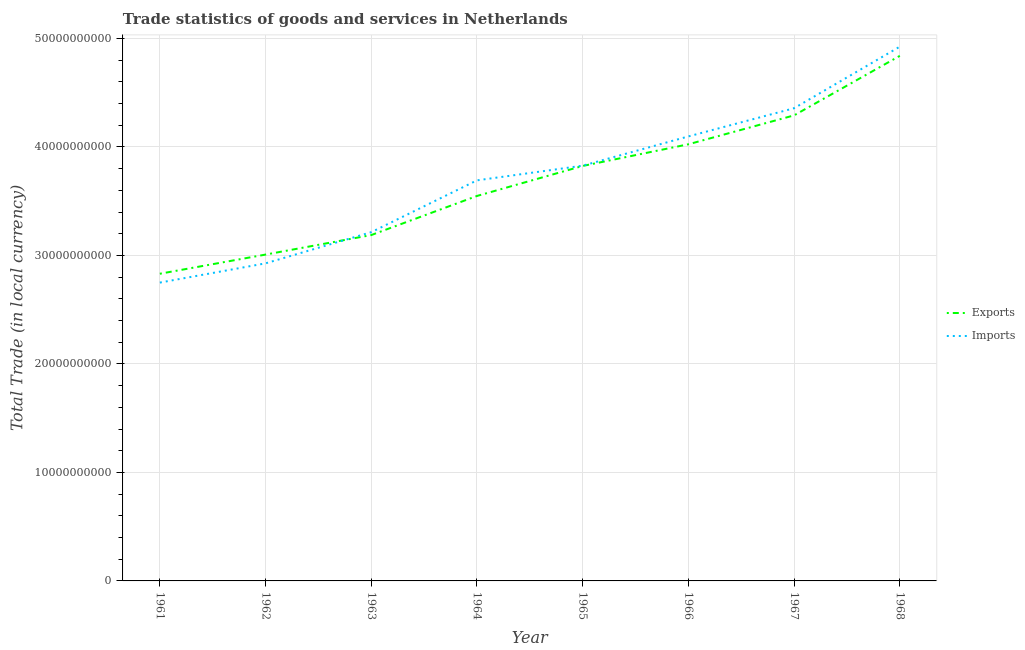Is the number of lines equal to the number of legend labels?
Give a very brief answer. Yes. What is the export of goods and services in 1962?
Make the answer very short. 3.01e+1. Across all years, what is the maximum export of goods and services?
Provide a short and direct response. 4.84e+1. Across all years, what is the minimum imports of goods and services?
Your response must be concise. 2.75e+1. In which year was the export of goods and services maximum?
Your response must be concise. 1968. What is the total export of goods and services in the graph?
Offer a terse response. 2.96e+11. What is the difference between the export of goods and services in 1962 and that in 1963?
Your response must be concise. -1.80e+09. What is the difference between the export of goods and services in 1964 and the imports of goods and services in 1965?
Provide a succinct answer. -2.79e+09. What is the average export of goods and services per year?
Provide a succinct answer. 3.69e+1. In the year 1963, what is the difference between the imports of goods and services and export of goods and services?
Provide a succinct answer. 2.67e+08. In how many years, is the export of goods and services greater than 46000000000 LCU?
Provide a short and direct response. 1. What is the ratio of the imports of goods and services in 1962 to that in 1964?
Provide a succinct answer. 0.79. Is the imports of goods and services in 1967 less than that in 1968?
Give a very brief answer. Yes. Is the difference between the export of goods and services in 1961 and 1966 greater than the difference between the imports of goods and services in 1961 and 1966?
Your answer should be very brief. Yes. What is the difference between the highest and the second highest imports of goods and services?
Your response must be concise. 5.67e+09. What is the difference between the highest and the lowest imports of goods and services?
Your response must be concise. 2.17e+1. Does the imports of goods and services monotonically increase over the years?
Give a very brief answer. Yes. How many years are there in the graph?
Make the answer very short. 8. What is the difference between two consecutive major ticks on the Y-axis?
Keep it short and to the point. 1.00e+1. Are the values on the major ticks of Y-axis written in scientific E-notation?
Your response must be concise. No. Does the graph contain any zero values?
Provide a short and direct response. No. Does the graph contain grids?
Your answer should be very brief. Yes. Where does the legend appear in the graph?
Keep it short and to the point. Center right. What is the title of the graph?
Provide a succinct answer. Trade statistics of goods and services in Netherlands. What is the label or title of the X-axis?
Your response must be concise. Year. What is the label or title of the Y-axis?
Give a very brief answer. Total Trade (in local currency). What is the Total Trade (in local currency) in Exports in 1961?
Make the answer very short. 2.83e+1. What is the Total Trade (in local currency) of Imports in 1961?
Your answer should be compact. 2.75e+1. What is the Total Trade (in local currency) in Exports in 1962?
Your answer should be very brief. 3.01e+1. What is the Total Trade (in local currency) of Imports in 1962?
Provide a succinct answer. 2.93e+1. What is the Total Trade (in local currency) of Exports in 1963?
Provide a short and direct response. 3.19e+1. What is the Total Trade (in local currency) of Imports in 1963?
Keep it short and to the point. 3.21e+1. What is the Total Trade (in local currency) of Exports in 1964?
Your response must be concise. 3.55e+1. What is the Total Trade (in local currency) of Imports in 1964?
Provide a succinct answer. 3.69e+1. What is the Total Trade (in local currency) in Exports in 1965?
Offer a terse response. 3.82e+1. What is the Total Trade (in local currency) in Imports in 1965?
Give a very brief answer. 3.83e+1. What is the Total Trade (in local currency) of Exports in 1966?
Offer a terse response. 4.02e+1. What is the Total Trade (in local currency) in Imports in 1966?
Keep it short and to the point. 4.10e+1. What is the Total Trade (in local currency) of Exports in 1967?
Your response must be concise. 4.29e+1. What is the Total Trade (in local currency) in Imports in 1967?
Make the answer very short. 4.36e+1. What is the Total Trade (in local currency) of Exports in 1968?
Keep it short and to the point. 4.84e+1. What is the Total Trade (in local currency) in Imports in 1968?
Provide a succinct answer. 4.92e+1. Across all years, what is the maximum Total Trade (in local currency) of Exports?
Your answer should be very brief. 4.84e+1. Across all years, what is the maximum Total Trade (in local currency) of Imports?
Give a very brief answer. 4.92e+1. Across all years, what is the minimum Total Trade (in local currency) of Exports?
Offer a very short reply. 2.83e+1. Across all years, what is the minimum Total Trade (in local currency) of Imports?
Offer a terse response. 2.75e+1. What is the total Total Trade (in local currency) in Exports in the graph?
Provide a short and direct response. 2.96e+11. What is the total Total Trade (in local currency) in Imports in the graph?
Make the answer very short. 2.98e+11. What is the difference between the Total Trade (in local currency) of Exports in 1961 and that in 1962?
Provide a succinct answer. -1.77e+09. What is the difference between the Total Trade (in local currency) in Imports in 1961 and that in 1962?
Offer a very short reply. -1.77e+09. What is the difference between the Total Trade (in local currency) in Exports in 1961 and that in 1963?
Ensure brevity in your answer.  -3.57e+09. What is the difference between the Total Trade (in local currency) of Imports in 1961 and that in 1963?
Provide a succinct answer. -4.65e+09. What is the difference between the Total Trade (in local currency) in Exports in 1961 and that in 1964?
Keep it short and to the point. -7.17e+09. What is the difference between the Total Trade (in local currency) in Imports in 1961 and that in 1964?
Offer a terse response. -9.42e+09. What is the difference between the Total Trade (in local currency) in Exports in 1961 and that in 1965?
Your response must be concise. -9.93e+09. What is the difference between the Total Trade (in local currency) of Imports in 1961 and that in 1965?
Your answer should be compact. -1.08e+1. What is the difference between the Total Trade (in local currency) in Exports in 1961 and that in 1966?
Your answer should be very brief. -1.19e+1. What is the difference between the Total Trade (in local currency) in Imports in 1961 and that in 1966?
Make the answer very short. -1.35e+1. What is the difference between the Total Trade (in local currency) of Exports in 1961 and that in 1967?
Offer a terse response. -1.46e+1. What is the difference between the Total Trade (in local currency) in Imports in 1961 and that in 1967?
Your response must be concise. -1.61e+1. What is the difference between the Total Trade (in local currency) of Exports in 1961 and that in 1968?
Give a very brief answer. -2.01e+1. What is the difference between the Total Trade (in local currency) in Imports in 1961 and that in 1968?
Your answer should be compact. -2.17e+1. What is the difference between the Total Trade (in local currency) of Exports in 1962 and that in 1963?
Your response must be concise. -1.80e+09. What is the difference between the Total Trade (in local currency) of Imports in 1962 and that in 1963?
Provide a short and direct response. -2.87e+09. What is the difference between the Total Trade (in local currency) in Exports in 1962 and that in 1964?
Provide a succinct answer. -5.40e+09. What is the difference between the Total Trade (in local currency) in Imports in 1962 and that in 1964?
Provide a short and direct response. -7.65e+09. What is the difference between the Total Trade (in local currency) of Exports in 1962 and that in 1965?
Give a very brief answer. -8.17e+09. What is the difference between the Total Trade (in local currency) in Imports in 1962 and that in 1965?
Provide a succinct answer. -9.00e+09. What is the difference between the Total Trade (in local currency) in Exports in 1962 and that in 1966?
Provide a succinct answer. -1.02e+1. What is the difference between the Total Trade (in local currency) of Imports in 1962 and that in 1966?
Make the answer very short. -1.17e+1. What is the difference between the Total Trade (in local currency) of Exports in 1962 and that in 1967?
Give a very brief answer. -1.28e+1. What is the difference between the Total Trade (in local currency) of Imports in 1962 and that in 1967?
Your answer should be compact. -1.43e+1. What is the difference between the Total Trade (in local currency) in Exports in 1962 and that in 1968?
Your answer should be compact. -1.83e+1. What is the difference between the Total Trade (in local currency) of Imports in 1962 and that in 1968?
Provide a short and direct response. -2.00e+1. What is the difference between the Total Trade (in local currency) in Exports in 1963 and that in 1964?
Provide a short and direct response. -3.60e+09. What is the difference between the Total Trade (in local currency) of Imports in 1963 and that in 1964?
Keep it short and to the point. -4.78e+09. What is the difference between the Total Trade (in local currency) of Exports in 1963 and that in 1965?
Your answer should be compact. -6.37e+09. What is the difference between the Total Trade (in local currency) in Imports in 1963 and that in 1965?
Provide a succinct answer. -6.13e+09. What is the difference between the Total Trade (in local currency) of Exports in 1963 and that in 1966?
Keep it short and to the point. -8.37e+09. What is the difference between the Total Trade (in local currency) in Imports in 1963 and that in 1966?
Offer a terse response. -8.82e+09. What is the difference between the Total Trade (in local currency) of Exports in 1963 and that in 1967?
Ensure brevity in your answer.  -1.10e+1. What is the difference between the Total Trade (in local currency) of Imports in 1963 and that in 1967?
Provide a succinct answer. -1.14e+1. What is the difference between the Total Trade (in local currency) in Exports in 1963 and that in 1968?
Keep it short and to the point. -1.65e+1. What is the difference between the Total Trade (in local currency) of Imports in 1963 and that in 1968?
Your answer should be compact. -1.71e+1. What is the difference between the Total Trade (in local currency) in Exports in 1964 and that in 1965?
Your answer should be compact. -2.77e+09. What is the difference between the Total Trade (in local currency) in Imports in 1964 and that in 1965?
Your answer should be compact. -1.35e+09. What is the difference between the Total Trade (in local currency) in Exports in 1964 and that in 1966?
Your answer should be compact. -4.76e+09. What is the difference between the Total Trade (in local currency) in Imports in 1964 and that in 1966?
Offer a very short reply. -4.05e+09. What is the difference between the Total Trade (in local currency) of Exports in 1964 and that in 1967?
Make the answer very short. -7.43e+09. What is the difference between the Total Trade (in local currency) of Imports in 1964 and that in 1967?
Provide a short and direct response. -6.65e+09. What is the difference between the Total Trade (in local currency) of Exports in 1964 and that in 1968?
Make the answer very short. -1.29e+1. What is the difference between the Total Trade (in local currency) of Imports in 1964 and that in 1968?
Ensure brevity in your answer.  -1.23e+1. What is the difference between the Total Trade (in local currency) in Exports in 1965 and that in 1966?
Ensure brevity in your answer.  -2.00e+09. What is the difference between the Total Trade (in local currency) of Imports in 1965 and that in 1966?
Keep it short and to the point. -2.70e+09. What is the difference between the Total Trade (in local currency) in Exports in 1965 and that in 1967?
Provide a succinct answer. -4.66e+09. What is the difference between the Total Trade (in local currency) of Imports in 1965 and that in 1967?
Your answer should be very brief. -5.29e+09. What is the difference between the Total Trade (in local currency) in Exports in 1965 and that in 1968?
Ensure brevity in your answer.  -1.01e+1. What is the difference between the Total Trade (in local currency) of Imports in 1965 and that in 1968?
Offer a very short reply. -1.10e+1. What is the difference between the Total Trade (in local currency) of Exports in 1966 and that in 1967?
Offer a very short reply. -2.66e+09. What is the difference between the Total Trade (in local currency) of Imports in 1966 and that in 1967?
Ensure brevity in your answer.  -2.60e+09. What is the difference between the Total Trade (in local currency) of Exports in 1966 and that in 1968?
Your response must be concise. -8.15e+09. What is the difference between the Total Trade (in local currency) in Imports in 1966 and that in 1968?
Give a very brief answer. -8.27e+09. What is the difference between the Total Trade (in local currency) of Exports in 1967 and that in 1968?
Offer a very short reply. -5.48e+09. What is the difference between the Total Trade (in local currency) in Imports in 1967 and that in 1968?
Ensure brevity in your answer.  -5.67e+09. What is the difference between the Total Trade (in local currency) of Exports in 1961 and the Total Trade (in local currency) of Imports in 1962?
Ensure brevity in your answer.  -9.59e+08. What is the difference between the Total Trade (in local currency) of Exports in 1961 and the Total Trade (in local currency) of Imports in 1963?
Offer a terse response. -3.83e+09. What is the difference between the Total Trade (in local currency) of Exports in 1961 and the Total Trade (in local currency) of Imports in 1964?
Your answer should be very brief. -8.61e+09. What is the difference between the Total Trade (in local currency) in Exports in 1961 and the Total Trade (in local currency) in Imports in 1965?
Provide a short and direct response. -9.96e+09. What is the difference between the Total Trade (in local currency) in Exports in 1961 and the Total Trade (in local currency) in Imports in 1966?
Ensure brevity in your answer.  -1.27e+1. What is the difference between the Total Trade (in local currency) in Exports in 1961 and the Total Trade (in local currency) in Imports in 1967?
Keep it short and to the point. -1.53e+1. What is the difference between the Total Trade (in local currency) of Exports in 1961 and the Total Trade (in local currency) of Imports in 1968?
Provide a succinct answer. -2.09e+1. What is the difference between the Total Trade (in local currency) in Exports in 1962 and the Total Trade (in local currency) in Imports in 1963?
Your answer should be compact. -2.06e+09. What is the difference between the Total Trade (in local currency) of Exports in 1962 and the Total Trade (in local currency) of Imports in 1964?
Offer a terse response. -6.84e+09. What is the difference between the Total Trade (in local currency) of Exports in 1962 and the Total Trade (in local currency) of Imports in 1965?
Offer a very short reply. -8.19e+09. What is the difference between the Total Trade (in local currency) of Exports in 1962 and the Total Trade (in local currency) of Imports in 1966?
Keep it short and to the point. -1.09e+1. What is the difference between the Total Trade (in local currency) in Exports in 1962 and the Total Trade (in local currency) in Imports in 1967?
Offer a terse response. -1.35e+1. What is the difference between the Total Trade (in local currency) in Exports in 1962 and the Total Trade (in local currency) in Imports in 1968?
Offer a terse response. -1.92e+1. What is the difference between the Total Trade (in local currency) in Exports in 1963 and the Total Trade (in local currency) in Imports in 1964?
Keep it short and to the point. -5.04e+09. What is the difference between the Total Trade (in local currency) in Exports in 1963 and the Total Trade (in local currency) in Imports in 1965?
Offer a terse response. -6.40e+09. What is the difference between the Total Trade (in local currency) of Exports in 1963 and the Total Trade (in local currency) of Imports in 1966?
Ensure brevity in your answer.  -9.09e+09. What is the difference between the Total Trade (in local currency) of Exports in 1963 and the Total Trade (in local currency) of Imports in 1967?
Provide a succinct answer. -1.17e+1. What is the difference between the Total Trade (in local currency) of Exports in 1963 and the Total Trade (in local currency) of Imports in 1968?
Ensure brevity in your answer.  -1.74e+1. What is the difference between the Total Trade (in local currency) of Exports in 1964 and the Total Trade (in local currency) of Imports in 1965?
Provide a succinct answer. -2.79e+09. What is the difference between the Total Trade (in local currency) in Exports in 1964 and the Total Trade (in local currency) in Imports in 1966?
Your answer should be compact. -5.49e+09. What is the difference between the Total Trade (in local currency) of Exports in 1964 and the Total Trade (in local currency) of Imports in 1967?
Give a very brief answer. -8.09e+09. What is the difference between the Total Trade (in local currency) of Exports in 1964 and the Total Trade (in local currency) of Imports in 1968?
Provide a short and direct response. -1.38e+1. What is the difference between the Total Trade (in local currency) in Exports in 1965 and the Total Trade (in local currency) in Imports in 1966?
Offer a terse response. -2.72e+09. What is the difference between the Total Trade (in local currency) of Exports in 1965 and the Total Trade (in local currency) of Imports in 1967?
Provide a short and direct response. -5.32e+09. What is the difference between the Total Trade (in local currency) in Exports in 1965 and the Total Trade (in local currency) in Imports in 1968?
Keep it short and to the point. -1.10e+1. What is the difference between the Total Trade (in local currency) of Exports in 1966 and the Total Trade (in local currency) of Imports in 1967?
Your answer should be very brief. -3.32e+09. What is the difference between the Total Trade (in local currency) in Exports in 1966 and the Total Trade (in local currency) in Imports in 1968?
Ensure brevity in your answer.  -9.00e+09. What is the difference between the Total Trade (in local currency) of Exports in 1967 and the Total Trade (in local currency) of Imports in 1968?
Provide a short and direct response. -6.33e+09. What is the average Total Trade (in local currency) in Exports per year?
Make the answer very short. 3.69e+1. What is the average Total Trade (in local currency) in Imports per year?
Your answer should be very brief. 3.72e+1. In the year 1961, what is the difference between the Total Trade (in local currency) of Exports and Total Trade (in local currency) of Imports?
Provide a succinct answer. 8.15e+08. In the year 1962, what is the difference between the Total Trade (in local currency) of Exports and Total Trade (in local currency) of Imports?
Your response must be concise. 8.08e+08. In the year 1963, what is the difference between the Total Trade (in local currency) of Exports and Total Trade (in local currency) of Imports?
Your answer should be very brief. -2.67e+08. In the year 1964, what is the difference between the Total Trade (in local currency) of Exports and Total Trade (in local currency) of Imports?
Provide a succinct answer. -1.44e+09. In the year 1965, what is the difference between the Total Trade (in local currency) of Exports and Total Trade (in local currency) of Imports?
Your answer should be very brief. -2.64e+07. In the year 1966, what is the difference between the Total Trade (in local currency) in Exports and Total Trade (in local currency) in Imports?
Make the answer very short. -7.24e+08. In the year 1967, what is the difference between the Total Trade (in local currency) in Exports and Total Trade (in local currency) in Imports?
Keep it short and to the point. -6.59e+08. In the year 1968, what is the difference between the Total Trade (in local currency) in Exports and Total Trade (in local currency) in Imports?
Make the answer very short. -8.47e+08. What is the ratio of the Total Trade (in local currency) of Exports in 1961 to that in 1962?
Your answer should be very brief. 0.94. What is the ratio of the Total Trade (in local currency) in Imports in 1961 to that in 1962?
Keep it short and to the point. 0.94. What is the ratio of the Total Trade (in local currency) of Exports in 1961 to that in 1963?
Your answer should be very brief. 0.89. What is the ratio of the Total Trade (in local currency) in Imports in 1961 to that in 1963?
Make the answer very short. 0.86. What is the ratio of the Total Trade (in local currency) in Exports in 1961 to that in 1964?
Provide a short and direct response. 0.8. What is the ratio of the Total Trade (in local currency) in Imports in 1961 to that in 1964?
Give a very brief answer. 0.74. What is the ratio of the Total Trade (in local currency) in Exports in 1961 to that in 1965?
Ensure brevity in your answer.  0.74. What is the ratio of the Total Trade (in local currency) of Imports in 1961 to that in 1965?
Ensure brevity in your answer.  0.72. What is the ratio of the Total Trade (in local currency) of Exports in 1961 to that in 1966?
Your response must be concise. 0.7. What is the ratio of the Total Trade (in local currency) in Imports in 1961 to that in 1966?
Offer a terse response. 0.67. What is the ratio of the Total Trade (in local currency) of Exports in 1961 to that in 1967?
Offer a very short reply. 0.66. What is the ratio of the Total Trade (in local currency) in Imports in 1961 to that in 1967?
Provide a short and direct response. 0.63. What is the ratio of the Total Trade (in local currency) in Exports in 1961 to that in 1968?
Your answer should be compact. 0.58. What is the ratio of the Total Trade (in local currency) of Imports in 1961 to that in 1968?
Your answer should be compact. 0.56. What is the ratio of the Total Trade (in local currency) in Exports in 1962 to that in 1963?
Keep it short and to the point. 0.94. What is the ratio of the Total Trade (in local currency) of Imports in 1962 to that in 1963?
Ensure brevity in your answer.  0.91. What is the ratio of the Total Trade (in local currency) of Exports in 1962 to that in 1964?
Offer a very short reply. 0.85. What is the ratio of the Total Trade (in local currency) of Imports in 1962 to that in 1964?
Offer a terse response. 0.79. What is the ratio of the Total Trade (in local currency) in Exports in 1962 to that in 1965?
Your answer should be compact. 0.79. What is the ratio of the Total Trade (in local currency) of Imports in 1962 to that in 1965?
Give a very brief answer. 0.76. What is the ratio of the Total Trade (in local currency) in Exports in 1962 to that in 1966?
Keep it short and to the point. 0.75. What is the ratio of the Total Trade (in local currency) of Imports in 1962 to that in 1966?
Your answer should be compact. 0.71. What is the ratio of the Total Trade (in local currency) in Exports in 1962 to that in 1967?
Provide a short and direct response. 0.7. What is the ratio of the Total Trade (in local currency) in Imports in 1962 to that in 1967?
Your response must be concise. 0.67. What is the ratio of the Total Trade (in local currency) of Exports in 1962 to that in 1968?
Keep it short and to the point. 0.62. What is the ratio of the Total Trade (in local currency) of Imports in 1962 to that in 1968?
Offer a very short reply. 0.59. What is the ratio of the Total Trade (in local currency) of Exports in 1963 to that in 1964?
Make the answer very short. 0.9. What is the ratio of the Total Trade (in local currency) in Imports in 1963 to that in 1964?
Keep it short and to the point. 0.87. What is the ratio of the Total Trade (in local currency) in Exports in 1963 to that in 1965?
Provide a succinct answer. 0.83. What is the ratio of the Total Trade (in local currency) of Imports in 1963 to that in 1965?
Make the answer very short. 0.84. What is the ratio of the Total Trade (in local currency) in Exports in 1963 to that in 1966?
Offer a terse response. 0.79. What is the ratio of the Total Trade (in local currency) in Imports in 1963 to that in 1966?
Ensure brevity in your answer.  0.78. What is the ratio of the Total Trade (in local currency) of Exports in 1963 to that in 1967?
Your response must be concise. 0.74. What is the ratio of the Total Trade (in local currency) in Imports in 1963 to that in 1967?
Your answer should be compact. 0.74. What is the ratio of the Total Trade (in local currency) of Exports in 1963 to that in 1968?
Keep it short and to the point. 0.66. What is the ratio of the Total Trade (in local currency) of Imports in 1963 to that in 1968?
Provide a short and direct response. 0.65. What is the ratio of the Total Trade (in local currency) of Exports in 1964 to that in 1965?
Offer a very short reply. 0.93. What is the ratio of the Total Trade (in local currency) of Imports in 1964 to that in 1965?
Offer a terse response. 0.96. What is the ratio of the Total Trade (in local currency) in Exports in 1964 to that in 1966?
Your answer should be compact. 0.88. What is the ratio of the Total Trade (in local currency) of Imports in 1964 to that in 1966?
Make the answer very short. 0.9. What is the ratio of the Total Trade (in local currency) in Exports in 1964 to that in 1967?
Your response must be concise. 0.83. What is the ratio of the Total Trade (in local currency) in Imports in 1964 to that in 1967?
Ensure brevity in your answer.  0.85. What is the ratio of the Total Trade (in local currency) in Exports in 1964 to that in 1968?
Your answer should be compact. 0.73. What is the ratio of the Total Trade (in local currency) in Imports in 1964 to that in 1968?
Your answer should be very brief. 0.75. What is the ratio of the Total Trade (in local currency) in Exports in 1965 to that in 1966?
Make the answer very short. 0.95. What is the ratio of the Total Trade (in local currency) in Imports in 1965 to that in 1966?
Your answer should be very brief. 0.93. What is the ratio of the Total Trade (in local currency) of Exports in 1965 to that in 1967?
Offer a very short reply. 0.89. What is the ratio of the Total Trade (in local currency) in Imports in 1965 to that in 1967?
Offer a terse response. 0.88. What is the ratio of the Total Trade (in local currency) in Exports in 1965 to that in 1968?
Offer a very short reply. 0.79. What is the ratio of the Total Trade (in local currency) in Imports in 1965 to that in 1968?
Offer a terse response. 0.78. What is the ratio of the Total Trade (in local currency) of Exports in 1966 to that in 1967?
Keep it short and to the point. 0.94. What is the ratio of the Total Trade (in local currency) of Imports in 1966 to that in 1967?
Offer a terse response. 0.94. What is the ratio of the Total Trade (in local currency) in Exports in 1966 to that in 1968?
Your response must be concise. 0.83. What is the ratio of the Total Trade (in local currency) of Imports in 1966 to that in 1968?
Offer a terse response. 0.83. What is the ratio of the Total Trade (in local currency) of Exports in 1967 to that in 1968?
Give a very brief answer. 0.89. What is the ratio of the Total Trade (in local currency) of Imports in 1967 to that in 1968?
Your answer should be compact. 0.88. What is the difference between the highest and the second highest Total Trade (in local currency) in Exports?
Your answer should be compact. 5.48e+09. What is the difference between the highest and the second highest Total Trade (in local currency) of Imports?
Offer a very short reply. 5.67e+09. What is the difference between the highest and the lowest Total Trade (in local currency) of Exports?
Provide a succinct answer. 2.01e+1. What is the difference between the highest and the lowest Total Trade (in local currency) in Imports?
Provide a succinct answer. 2.17e+1. 